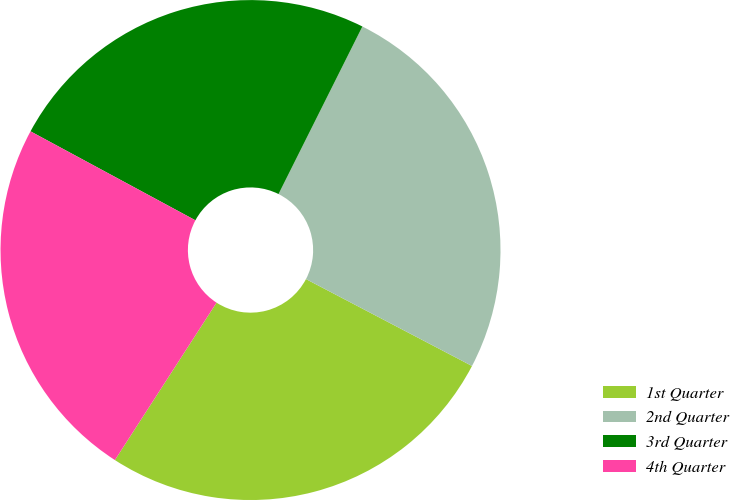<chart> <loc_0><loc_0><loc_500><loc_500><pie_chart><fcel>1st Quarter<fcel>2nd Quarter<fcel>3rd Quarter<fcel>4th Quarter<nl><fcel>26.45%<fcel>25.29%<fcel>24.51%<fcel>23.75%<nl></chart> 